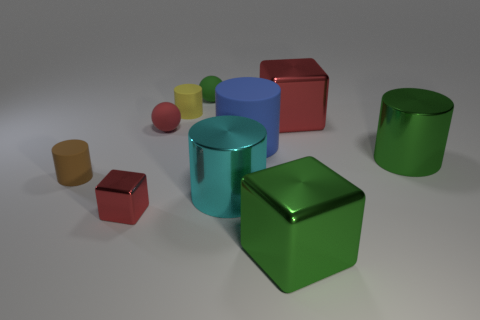There is a green thing that is the same shape as the small red matte object; what is its material?
Keep it short and to the point. Rubber. There is a tiny ball that is the same color as the small metallic object; what is it made of?
Make the answer very short. Rubber. What number of large cyan shiny things are to the left of the cylinder that is behind the red shiny cube that is behind the tiny brown matte thing?
Your answer should be compact. 0. Is the number of large green metal cylinders in front of the large green metal cylinder greater than the number of yellow matte things to the right of the yellow rubber thing?
Your answer should be compact. No. How many objects are big green metallic things that are in front of the tiny brown thing or metallic things that are in front of the large matte cylinder?
Provide a short and direct response. 4. What material is the red block that is in front of the red cube that is right of the red metallic thing in front of the green metallic cylinder made of?
Provide a short and direct response. Metal. Is the color of the large metallic cylinder that is right of the blue cylinder the same as the big matte cylinder?
Ensure brevity in your answer.  No. The block that is in front of the brown cylinder and on the right side of the tiny red cube is made of what material?
Give a very brief answer. Metal. Do the small green ball and the big blue thing have the same material?
Your response must be concise. Yes. How many tiny rubber objects are on the right side of the small shiny thing and in front of the small green rubber ball?
Your answer should be very brief. 2. 